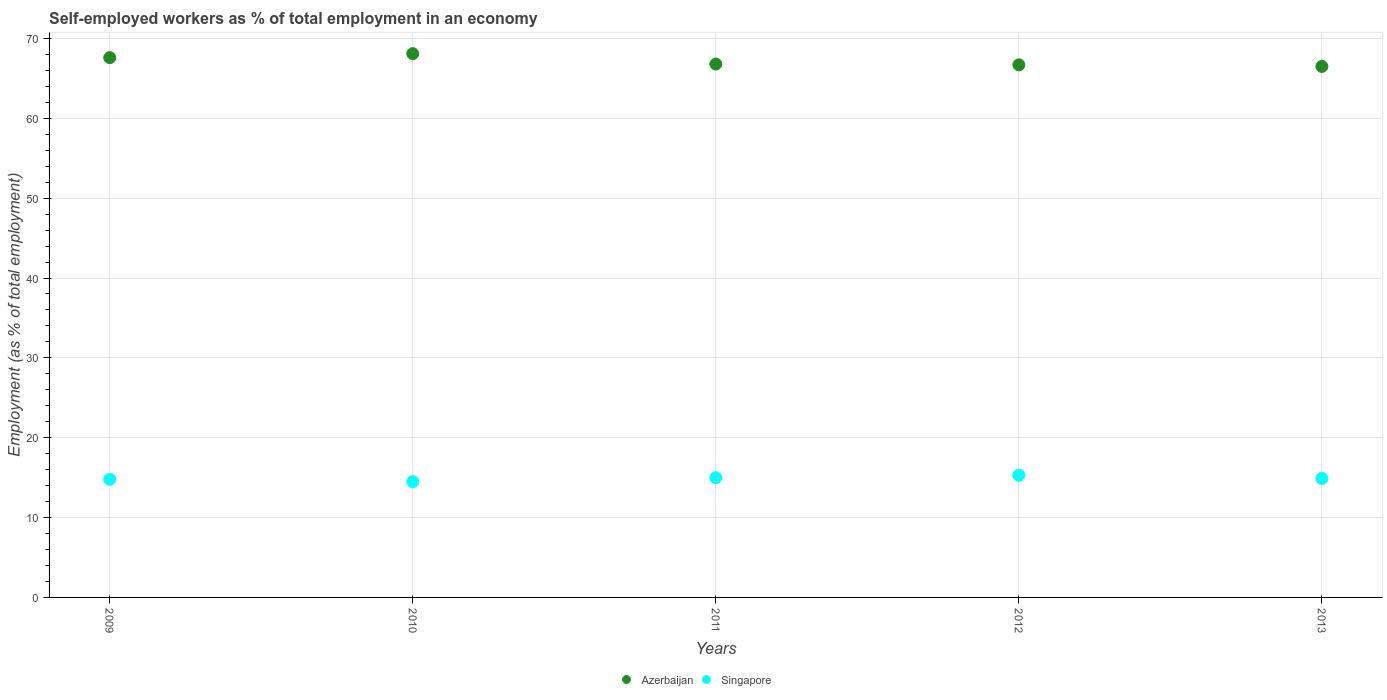Is the number of dotlines equal to the number of legend labels?
Your answer should be compact. Yes. What is the percentage of self-employed workers in Singapore in 2009?
Make the answer very short. 14.8. Across all years, what is the maximum percentage of self-employed workers in Azerbaijan?
Offer a very short reply. 68.1. In which year was the percentage of self-employed workers in Singapore maximum?
Provide a short and direct response. 2012. In which year was the percentage of self-employed workers in Azerbaijan minimum?
Provide a succinct answer. 2013. What is the total percentage of self-employed workers in Azerbaijan in the graph?
Your answer should be very brief. 335.7. What is the difference between the percentage of self-employed workers in Azerbaijan in 2010 and that in 2011?
Make the answer very short. 1.3. What is the difference between the percentage of self-employed workers in Azerbaijan in 2011 and the percentage of self-employed workers in Singapore in 2009?
Your answer should be compact. 52. What is the average percentage of self-employed workers in Azerbaijan per year?
Give a very brief answer. 67.14. In the year 2013, what is the difference between the percentage of self-employed workers in Azerbaijan and percentage of self-employed workers in Singapore?
Your response must be concise. 51.6. In how many years, is the percentage of self-employed workers in Singapore greater than 66 %?
Provide a succinct answer. 0. What is the ratio of the percentage of self-employed workers in Azerbaijan in 2010 to that in 2013?
Make the answer very short. 1.02. Is the percentage of self-employed workers in Singapore in 2009 less than that in 2012?
Make the answer very short. Yes. What is the difference between the highest and the lowest percentage of self-employed workers in Singapore?
Give a very brief answer. 0.8. In how many years, is the percentage of self-employed workers in Singapore greater than the average percentage of self-employed workers in Singapore taken over all years?
Offer a very short reply. 2. Is the percentage of self-employed workers in Singapore strictly greater than the percentage of self-employed workers in Azerbaijan over the years?
Ensure brevity in your answer.  No. Is the percentage of self-employed workers in Azerbaijan strictly less than the percentage of self-employed workers in Singapore over the years?
Provide a short and direct response. No. How many dotlines are there?
Your answer should be very brief. 2. What is the difference between two consecutive major ticks on the Y-axis?
Ensure brevity in your answer.  10. Are the values on the major ticks of Y-axis written in scientific E-notation?
Provide a succinct answer. No. Does the graph contain any zero values?
Give a very brief answer. No. How many legend labels are there?
Offer a very short reply. 2. How are the legend labels stacked?
Make the answer very short. Horizontal. What is the title of the graph?
Keep it short and to the point. Self-employed workers as % of total employment in an economy. What is the label or title of the Y-axis?
Give a very brief answer. Employment (as % of total employment). What is the Employment (as % of total employment) in Azerbaijan in 2009?
Ensure brevity in your answer.  67.6. What is the Employment (as % of total employment) of Singapore in 2009?
Offer a very short reply. 14.8. What is the Employment (as % of total employment) of Azerbaijan in 2010?
Provide a succinct answer. 68.1. What is the Employment (as % of total employment) in Azerbaijan in 2011?
Offer a terse response. 66.8. What is the Employment (as % of total employment) in Azerbaijan in 2012?
Keep it short and to the point. 66.7. What is the Employment (as % of total employment) of Singapore in 2012?
Offer a terse response. 15.3. What is the Employment (as % of total employment) in Azerbaijan in 2013?
Give a very brief answer. 66.5. What is the Employment (as % of total employment) of Singapore in 2013?
Your answer should be compact. 14.9. Across all years, what is the maximum Employment (as % of total employment) in Azerbaijan?
Offer a terse response. 68.1. Across all years, what is the maximum Employment (as % of total employment) in Singapore?
Keep it short and to the point. 15.3. Across all years, what is the minimum Employment (as % of total employment) of Azerbaijan?
Ensure brevity in your answer.  66.5. Across all years, what is the minimum Employment (as % of total employment) in Singapore?
Ensure brevity in your answer.  14.5. What is the total Employment (as % of total employment) in Azerbaijan in the graph?
Ensure brevity in your answer.  335.7. What is the total Employment (as % of total employment) of Singapore in the graph?
Provide a short and direct response. 74.5. What is the difference between the Employment (as % of total employment) of Singapore in 2009 and that in 2011?
Offer a terse response. -0.2. What is the difference between the Employment (as % of total employment) of Azerbaijan in 2009 and that in 2012?
Make the answer very short. 0.9. What is the difference between the Employment (as % of total employment) of Singapore in 2009 and that in 2012?
Give a very brief answer. -0.5. What is the difference between the Employment (as % of total employment) in Azerbaijan in 2009 and that in 2013?
Provide a succinct answer. 1.1. What is the difference between the Employment (as % of total employment) of Singapore in 2009 and that in 2013?
Offer a very short reply. -0.1. What is the difference between the Employment (as % of total employment) of Azerbaijan in 2010 and that in 2011?
Offer a terse response. 1.3. What is the difference between the Employment (as % of total employment) in Azerbaijan in 2010 and that in 2012?
Your response must be concise. 1.4. What is the difference between the Employment (as % of total employment) in Singapore in 2010 and that in 2012?
Your answer should be compact. -0.8. What is the difference between the Employment (as % of total employment) in Azerbaijan in 2010 and that in 2013?
Keep it short and to the point. 1.6. What is the difference between the Employment (as % of total employment) of Singapore in 2010 and that in 2013?
Make the answer very short. -0.4. What is the difference between the Employment (as % of total employment) of Azerbaijan in 2011 and that in 2013?
Give a very brief answer. 0.3. What is the difference between the Employment (as % of total employment) in Singapore in 2011 and that in 2013?
Your answer should be compact. 0.1. What is the difference between the Employment (as % of total employment) of Azerbaijan in 2012 and that in 2013?
Your answer should be very brief. 0.2. What is the difference between the Employment (as % of total employment) of Singapore in 2012 and that in 2013?
Ensure brevity in your answer.  0.4. What is the difference between the Employment (as % of total employment) of Azerbaijan in 2009 and the Employment (as % of total employment) of Singapore in 2010?
Provide a short and direct response. 53.1. What is the difference between the Employment (as % of total employment) in Azerbaijan in 2009 and the Employment (as % of total employment) in Singapore in 2011?
Ensure brevity in your answer.  52.6. What is the difference between the Employment (as % of total employment) in Azerbaijan in 2009 and the Employment (as % of total employment) in Singapore in 2012?
Make the answer very short. 52.3. What is the difference between the Employment (as % of total employment) in Azerbaijan in 2009 and the Employment (as % of total employment) in Singapore in 2013?
Make the answer very short. 52.7. What is the difference between the Employment (as % of total employment) in Azerbaijan in 2010 and the Employment (as % of total employment) in Singapore in 2011?
Your response must be concise. 53.1. What is the difference between the Employment (as % of total employment) of Azerbaijan in 2010 and the Employment (as % of total employment) of Singapore in 2012?
Ensure brevity in your answer.  52.8. What is the difference between the Employment (as % of total employment) in Azerbaijan in 2010 and the Employment (as % of total employment) in Singapore in 2013?
Ensure brevity in your answer.  53.2. What is the difference between the Employment (as % of total employment) of Azerbaijan in 2011 and the Employment (as % of total employment) of Singapore in 2012?
Give a very brief answer. 51.5. What is the difference between the Employment (as % of total employment) in Azerbaijan in 2011 and the Employment (as % of total employment) in Singapore in 2013?
Provide a short and direct response. 51.9. What is the difference between the Employment (as % of total employment) of Azerbaijan in 2012 and the Employment (as % of total employment) of Singapore in 2013?
Offer a terse response. 51.8. What is the average Employment (as % of total employment) in Azerbaijan per year?
Give a very brief answer. 67.14. In the year 2009, what is the difference between the Employment (as % of total employment) of Azerbaijan and Employment (as % of total employment) of Singapore?
Your answer should be compact. 52.8. In the year 2010, what is the difference between the Employment (as % of total employment) in Azerbaijan and Employment (as % of total employment) in Singapore?
Your answer should be very brief. 53.6. In the year 2011, what is the difference between the Employment (as % of total employment) in Azerbaijan and Employment (as % of total employment) in Singapore?
Your answer should be very brief. 51.8. In the year 2012, what is the difference between the Employment (as % of total employment) in Azerbaijan and Employment (as % of total employment) in Singapore?
Your answer should be very brief. 51.4. In the year 2013, what is the difference between the Employment (as % of total employment) in Azerbaijan and Employment (as % of total employment) in Singapore?
Give a very brief answer. 51.6. What is the ratio of the Employment (as % of total employment) of Singapore in 2009 to that in 2010?
Your response must be concise. 1.02. What is the ratio of the Employment (as % of total employment) of Singapore in 2009 to that in 2011?
Ensure brevity in your answer.  0.99. What is the ratio of the Employment (as % of total employment) of Azerbaijan in 2009 to that in 2012?
Your answer should be very brief. 1.01. What is the ratio of the Employment (as % of total employment) of Singapore in 2009 to that in 2012?
Make the answer very short. 0.97. What is the ratio of the Employment (as % of total employment) of Azerbaijan in 2009 to that in 2013?
Provide a short and direct response. 1.02. What is the ratio of the Employment (as % of total employment) in Azerbaijan in 2010 to that in 2011?
Your response must be concise. 1.02. What is the ratio of the Employment (as % of total employment) of Singapore in 2010 to that in 2011?
Make the answer very short. 0.97. What is the ratio of the Employment (as % of total employment) in Singapore in 2010 to that in 2012?
Make the answer very short. 0.95. What is the ratio of the Employment (as % of total employment) of Azerbaijan in 2010 to that in 2013?
Give a very brief answer. 1.02. What is the ratio of the Employment (as % of total employment) of Singapore in 2010 to that in 2013?
Your answer should be very brief. 0.97. What is the ratio of the Employment (as % of total employment) in Singapore in 2011 to that in 2012?
Keep it short and to the point. 0.98. What is the ratio of the Employment (as % of total employment) in Singapore in 2011 to that in 2013?
Your answer should be compact. 1.01. What is the ratio of the Employment (as % of total employment) of Azerbaijan in 2012 to that in 2013?
Your answer should be compact. 1. What is the ratio of the Employment (as % of total employment) of Singapore in 2012 to that in 2013?
Provide a short and direct response. 1.03. What is the difference between the highest and the second highest Employment (as % of total employment) of Singapore?
Give a very brief answer. 0.3. What is the difference between the highest and the lowest Employment (as % of total employment) of Azerbaijan?
Your answer should be very brief. 1.6. What is the difference between the highest and the lowest Employment (as % of total employment) in Singapore?
Offer a terse response. 0.8. 